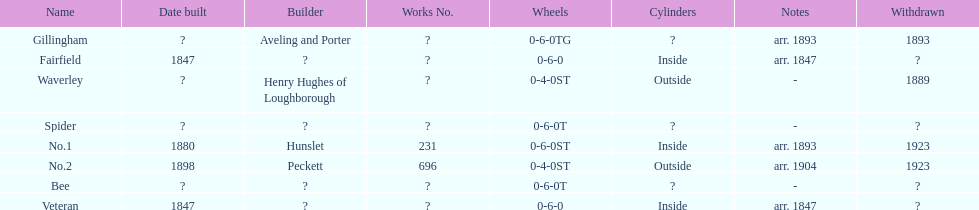How long after fairfield was no. 1 built? 33 years. 